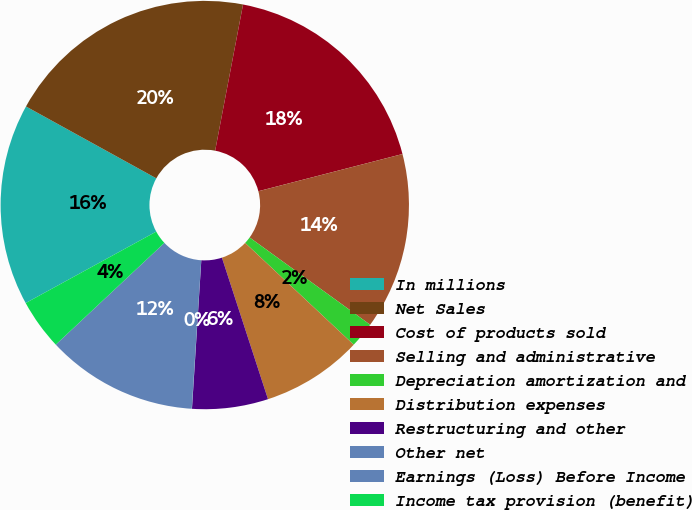<chart> <loc_0><loc_0><loc_500><loc_500><pie_chart><fcel>In millions<fcel>Net Sales<fcel>Cost of products sold<fcel>Selling and administrative<fcel>Depreciation amortization and<fcel>Distribution expenses<fcel>Restructuring and other<fcel>Other net<fcel>Earnings (Loss) Before Income<fcel>Income tax provision (benefit)<nl><fcel>15.99%<fcel>19.98%<fcel>17.98%<fcel>13.99%<fcel>2.02%<fcel>8.0%<fcel>6.01%<fcel>0.02%<fcel>12.0%<fcel>4.01%<nl></chart> 